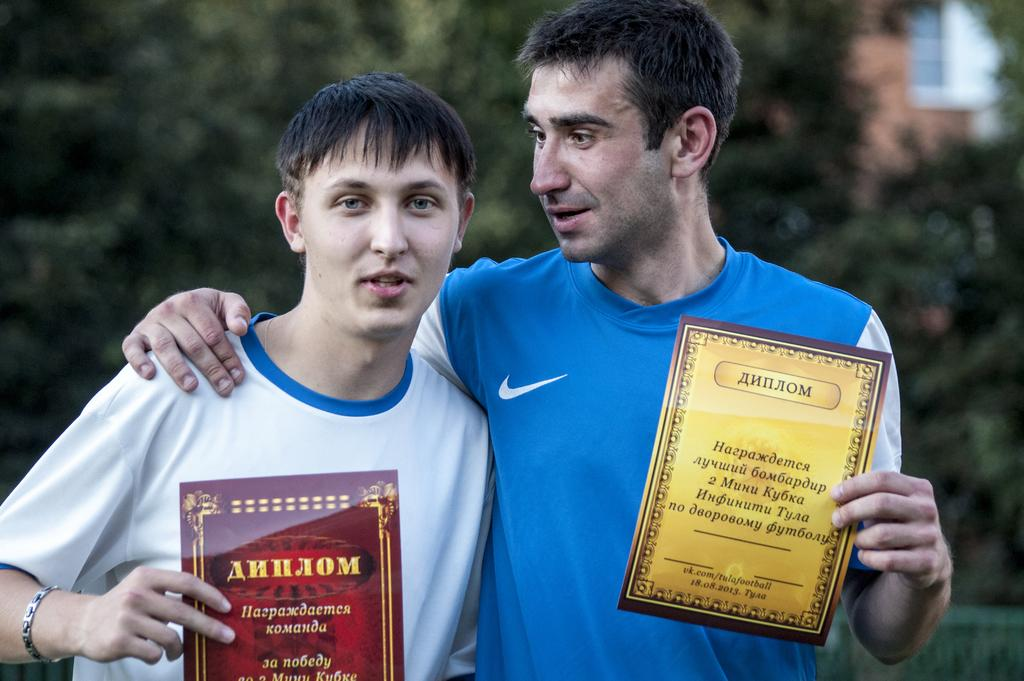How many people are in the foreground of the image? There are two persons in the foreground of the image. What are the persons holding in their hands? The persons are holding certificates in their hands. What can be seen in the background of the image? There are trees and a building wall in the background of the image. When was the image taken? The image was taken during the day. What type of house is visible in the image? There is no house visible in the image; only trees and a building wall are present in the background. What organization is responsible for the certificates held by the persons in the image? The image does not provide any information about the organization responsible for the certificates. 